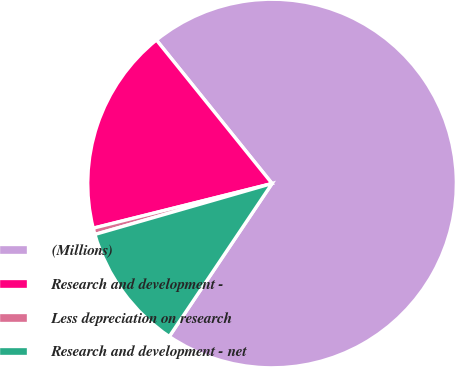<chart> <loc_0><loc_0><loc_500><loc_500><pie_chart><fcel>(Millions)<fcel>Research and development -<fcel>Less depreciation on research<fcel>Research and development - net<nl><fcel>70.21%<fcel>18.1%<fcel>0.56%<fcel>11.13%<nl></chart> 